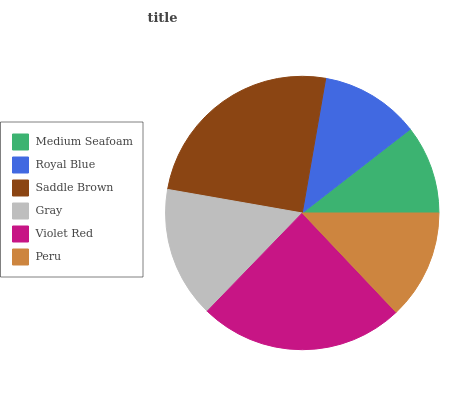Is Medium Seafoam the minimum?
Answer yes or no. Yes. Is Saddle Brown the maximum?
Answer yes or no. Yes. Is Royal Blue the minimum?
Answer yes or no. No. Is Royal Blue the maximum?
Answer yes or no. No. Is Royal Blue greater than Medium Seafoam?
Answer yes or no. Yes. Is Medium Seafoam less than Royal Blue?
Answer yes or no. Yes. Is Medium Seafoam greater than Royal Blue?
Answer yes or no. No. Is Royal Blue less than Medium Seafoam?
Answer yes or no. No. Is Gray the high median?
Answer yes or no. Yes. Is Peru the low median?
Answer yes or no. Yes. Is Saddle Brown the high median?
Answer yes or no. No. Is Gray the low median?
Answer yes or no. No. 